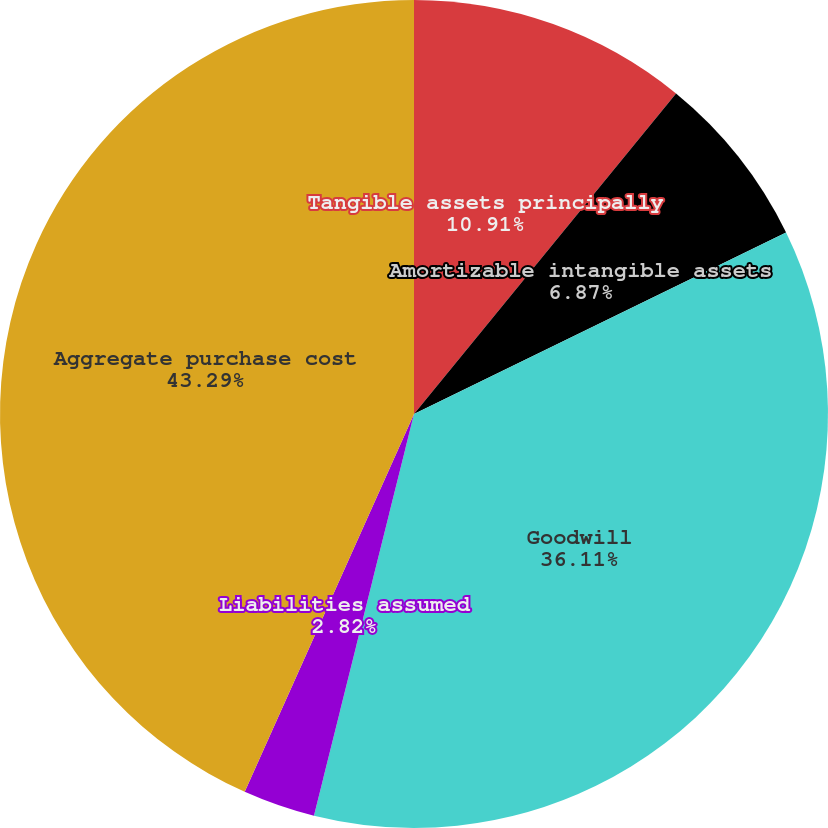Convert chart to OTSL. <chart><loc_0><loc_0><loc_500><loc_500><pie_chart><fcel>Tangible assets principally<fcel>Amortizable intangible assets<fcel>Goodwill<fcel>Liabilities assumed<fcel>Aggregate purchase cost<nl><fcel>10.91%<fcel>6.87%<fcel>36.11%<fcel>2.82%<fcel>43.3%<nl></chart> 